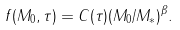Convert formula to latex. <formula><loc_0><loc_0><loc_500><loc_500>f ( M _ { 0 } , \tau ) = C ( \tau ) ( M _ { 0 } / M _ { * } ) ^ { \beta } .</formula> 